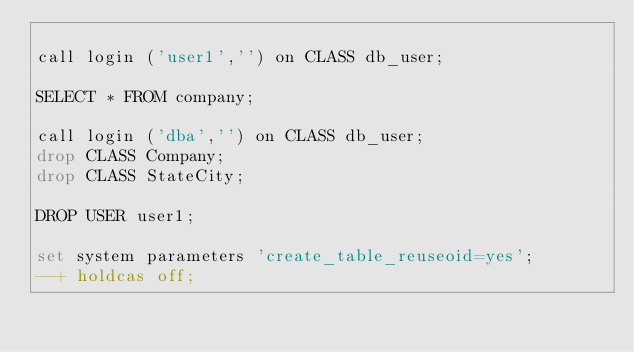Convert code to text. <code><loc_0><loc_0><loc_500><loc_500><_SQL_>
call login ('user1','') on CLASS db_user;

SELECT * FROM company;

call login ('dba','') on CLASS db_user;
drop CLASS Company;
drop CLASS StateCity;

DROP USER user1;

set system parameters 'create_table_reuseoid=yes';
--+ holdcas off;
</code> 